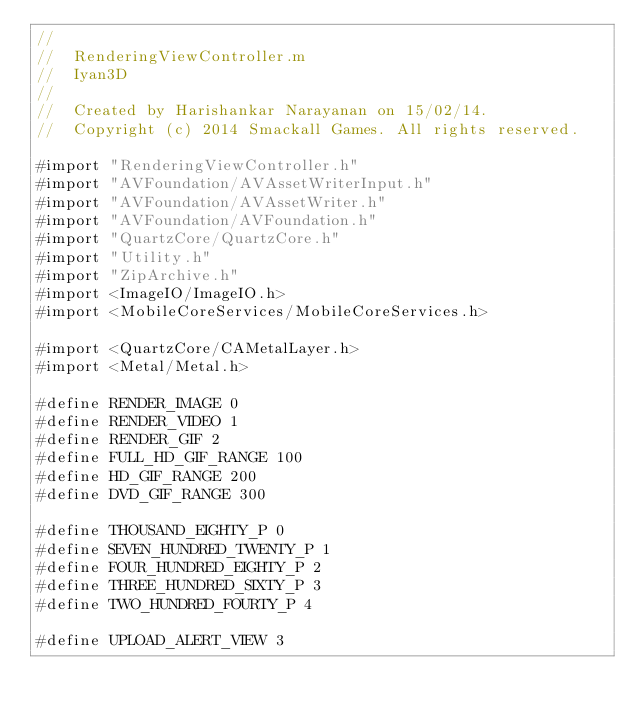<code> <loc_0><loc_0><loc_500><loc_500><_ObjectiveC_>//
//  RenderingViewController.m
//  Iyan3D
//
//  Created by Harishankar Narayanan on 15/02/14.
//  Copyright (c) 2014 Smackall Games. All rights reserved.

#import "RenderingViewController.h"
#import "AVFoundation/AVAssetWriterInput.h"
#import "AVFoundation/AVAssetWriter.h"
#import "AVFoundation/AVFoundation.h"
#import "QuartzCore/QuartzCore.h"
#import "Utility.h"
#import "ZipArchive.h"
#import <ImageIO/ImageIO.h>
#import <MobileCoreServices/MobileCoreServices.h>

#import <QuartzCore/CAMetalLayer.h>
#import <Metal/Metal.h>

#define RENDER_IMAGE 0
#define RENDER_VIDEO 1
#define RENDER_GIF 2
#define FULL_HD_GIF_RANGE 100
#define HD_GIF_RANGE 200
#define DVD_GIF_RANGE 300

#define THOUSAND_EIGHTY_P 0
#define SEVEN_HUNDRED_TWENTY_P 1
#define FOUR_HUNDRED_EIGHTY_P 2
#define THREE_HUNDRED_SIXTY_P 3
#define TWO_HUNDRED_FOURTY_P 4

#define UPLOAD_ALERT_VIEW 3</code> 